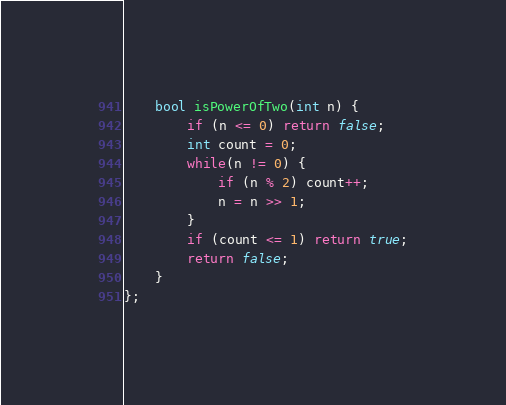Convert code to text. <code><loc_0><loc_0><loc_500><loc_500><_C++_>    bool isPowerOfTwo(int n) {
        if (n <= 0) return false;
        int count = 0;
        while(n != 0) {
            if (n % 2) count++;
            n = n >> 1;
        }
        if (count <= 1) return true;
        return false;
    }
};
</code> 